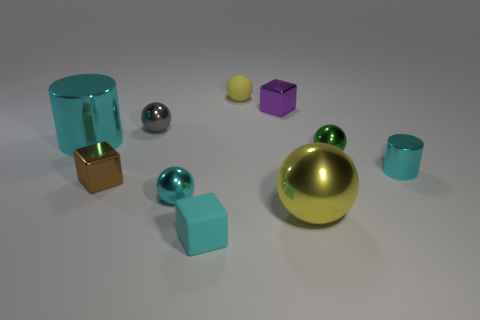Are there an equal number of blocks that are in front of the green metallic object and small blocks that are left of the tiny yellow rubber ball?
Provide a succinct answer. Yes. What number of other things are the same shape as the large yellow shiny object?
Make the answer very short. 4. There is a cyan metal cylinder that is on the right side of the brown object; is it the same size as the matte thing in front of the purple metal thing?
Your response must be concise. Yes. How many cylinders are tiny gray objects or brown metal objects?
Your response must be concise. 0. How many metallic objects are either green things or tiny spheres?
Your answer should be very brief. 3. There is a yellow metallic thing that is the same shape as the tiny green thing; what is its size?
Offer a very short reply. Large. There is a green shiny ball; is its size the same as the yellow object that is on the left side of the tiny purple object?
Your answer should be compact. Yes. There is a large metal object that is on the right side of the small purple block; what is its shape?
Your answer should be very brief. Sphere. There is a small block in front of the yellow sphere in front of the green object; what is its color?
Offer a terse response. Cyan. There is another rubber thing that is the same shape as the big yellow thing; what is its color?
Ensure brevity in your answer.  Yellow. 